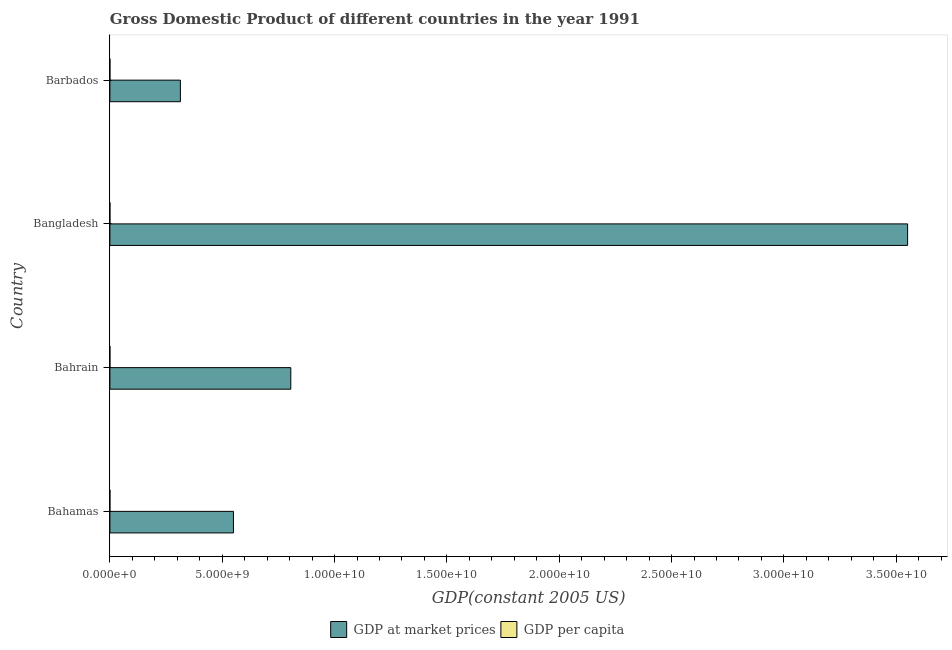Are the number of bars on each tick of the Y-axis equal?
Ensure brevity in your answer.  Yes. How many bars are there on the 4th tick from the bottom?
Provide a short and direct response. 2. What is the label of the 3rd group of bars from the top?
Give a very brief answer. Bahrain. In how many cases, is the number of bars for a given country not equal to the number of legend labels?
Keep it short and to the point. 0. What is the gdp at market prices in Bahamas?
Provide a succinct answer. 5.50e+09. Across all countries, what is the maximum gdp per capita?
Your answer should be very brief. 2.11e+04. Across all countries, what is the minimum gdp at market prices?
Offer a terse response. 3.14e+09. In which country was the gdp at market prices minimum?
Ensure brevity in your answer.  Barbados. What is the total gdp per capita in the graph?
Offer a very short reply. 4.92e+04. What is the difference between the gdp per capita in Bahrain and that in Barbados?
Your answer should be very brief. 3789.09. What is the difference between the gdp at market prices in Bahamas and the gdp per capita in Barbados?
Your answer should be very brief. 5.50e+09. What is the average gdp at market prices per country?
Make the answer very short. 1.30e+1. What is the difference between the gdp at market prices and gdp per capita in Bahrain?
Offer a very short reply. 8.05e+09. In how many countries, is the gdp per capita greater than 19000000000 US$?
Provide a succinct answer. 0. What is the ratio of the gdp per capita in Bahamas to that in Bangladesh?
Your answer should be compact. 64.36. What is the difference between the highest and the second highest gdp at market prices?
Provide a short and direct response. 2.75e+1. What is the difference between the highest and the lowest gdp per capita?
Offer a terse response. 2.07e+04. In how many countries, is the gdp at market prices greater than the average gdp at market prices taken over all countries?
Your answer should be compact. 1. Is the sum of the gdp per capita in Bahamas and Bahrain greater than the maximum gdp at market prices across all countries?
Offer a terse response. No. What does the 1st bar from the top in Bangladesh represents?
Ensure brevity in your answer.  GDP per capita. What does the 2nd bar from the bottom in Bangladesh represents?
Your answer should be very brief. GDP per capita. How many bars are there?
Provide a succinct answer. 8. How many countries are there in the graph?
Make the answer very short. 4. What is the difference between two consecutive major ticks on the X-axis?
Keep it short and to the point. 5.00e+09. Where does the legend appear in the graph?
Offer a very short reply. Bottom center. What is the title of the graph?
Offer a very short reply. Gross Domestic Product of different countries in the year 1991. What is the label or title of the X-axis?
Keep it short and to the point. GDP(constant 2005 US). What is the label or title of the Y-axis?
Your response must be concise. Country. What is the GDP(constant 2005 US) of GDP at market prices in Bahamas?
Make the answer very short. 5.50e+09. What is the GDP(constant 2005 US) of GDP per capita in Bahamas?
Your response must be concise. 2.11e+04. What is the GDP(constant 2005 US) in GDP at market prices in Bahrain?
Your answer should be compact. 8.05e+09. What is the GDP(constant 2005 US) of GDP per capita in Bahrain?
Your answer should be compact. 1.58e+04. What is the GDP(constant 2005 US) in GDP at market prices in Bangladesh?
Your answer should be very brief. 3.55e+1. What is the GDP(constant 2005 US) in GDP per capita in Bangladesh?
Provide a succinct answer. 327.21. What is the GDP(constant 2005 US) of GDP at market prices in Barbados?
Offer a terse response. 3.14e+09. What is the GDP(constant 2005 US) of GDP per capita in Barbados?
Your response must be concise. 1.20e+04. Across all countries, what is the maximum GDP(constant 2005 US) of GDP at market prices?
Your answer should be compact. 3.55e+1. Across all countries, what is the maximum GDP(constant 2005 US) of GDP per capita?
Make the answer very short. 2.11e+04. Across all countries, what is the minimum GDP(constant 2005 US) of GDP at market prices?
Give a very brief answer. 3.14e+09. Across all countries, what is the minimum GDP(constant 2005 US) in GDP per capita?
Your answer should be compact. 327.21. What is the total GDP(constant 2005 US) of GDP at market prices in the graph?
Keep it short and to the point. 5.22e+1. What is the total GDP(constant 2005 US) in GDP per capita in the graph?
Make the answer very short. 4.92e+04. What is the difference between the GDP(constant 2005 US) of GDP at market prices in Bahamas and that in Bahrain?
Provide a succinct answer. -2.55e+09. What is the difference between the GDP(constant 2005 US) in GDP per capita in Bahamas and that in Bahrain?
Your answer should be very brief. 5259.74. What is the difference between the GDP(constant 2005 US) in GDP at market prices in Bahamas and that in Bangladesh?
Your answer should be compact. -3.00e+1. What is the difference between the GDP(constant 2005 US) in GDP per capita in Bahamas and that in Bangladesh?
Give a very brief answer. 2.07e+04. What is the difference between the GDP(constant 2005 US) of GDP at market prices in Bahamas and that in Barbados?
Offer a very short reply. 2.36e+09. What is the difference between the GDP(constant 2005 US) in GDP per capita in Bahamas and that in Barbados?
Provide a succinct answer. 9048.83. What is the difference between the GDP(constant 2005 US) of GDP at market prices in Bahrain and that in Bangladesh?
Offer a terse response. -2.75e+1. What is the difference between the GDP(constant 2005 US) of GDP per capita in Bahrain and that in Bangladesh?
Give a very brief answer. 1.55e+04. What is the difference between the GDP(constant 2005 US) in GDP at market prices in Bahrain and that in Barbados?
Keep it short and to the point. 4.91e+09. What is the difference between the GDP(constant 2005 US) in GDP per capita in Bahrain and that in Barbados?
Give a very brief answer. 3789.09. What is the difference between the GDP(constant 2005 US) in GDP at market prices in Bangladesh and that in Barbados?
Give a very brief answer. 3.24e+1. What is the difference between the GDP(constant 2005 US) in GDP per capita in Bangladesh and that in Barbados?
Make the answer very short. -1.17e+04. What is the difference between the GDP(constant 2005 US) in GDP at market prices in Bahamas and the GDP(constant 2005 US) in GDP per capita in Bahrain?
Provide a succinct answer. 5.50e+09. What is the difference between the GDP(constant 2005 US) of GDP at market prices in Bahamas and the GDP(constant 2005 US) of GDP per capita in Bangladesh?
Your response must be concise. 5.50e+09. What is the difference between the GDP(constant 2005 US) of GDP at market prices in Bahamas and the GDP(constant 2005 US) of GDP per capita in Barbados?
Your answer should be very brief. 5.50e+09. What is the difference between the GDP(constant 2005 US) of GDP at market prices in Bahrain and the GDP(constant 2005 US) of GDP per capita in Bangladesh?
Provide a short and direct response. 8.05e+09. What is the difference between the GDP(constant 2005 US) in GDP at market prices in Bahrain and the GDP(constant 2005 US) in GDP per capita in Barbados?
Provide a short and direct response. 8.05e+09. What is the difference between the GDP(constant 2005 US) of GDP at market prices in Bangladesh and the GDP(constant 2005 US) of GDP per capita in Barbados?
Provide a short and direct response. 3.55e+1. What is the average GDP(constant 2005 US) of GDP at market prices per country?
Offer a very short reply. 1.30e+1. What is the average GDP(constant 2005 US) in GDP per capita per country?
Give a very brief answer. 1.23e+04. What is the difference between the GDP(constant 2005 US) of GDP at market prices and GDP(constant 2005 US) of GDP per capita in Bahamas?
Your response must be concise. 5.50e+09. What is the difference between the GDP(constant 2005 US) in GDP at market prices and GDP(constant 2005 US) in GDP per capita in Bahrain?
Ensure brevity in your answer.  8.05e+09. What is the difference between the GDP(constant 2005 US) in GDP at market prices and GDP(constant 2005 US) in GDP per capita in Bangladesh?
Keep it short and to the point. 3.55e+1. What is the difference between the GDP(constant 2005 US) in GDP at market prices and GDP(constant 2005 US) in GDP per capita in Barbados?
Your answer should be compact. 3.14e+09. What is the ratio of the GDP(constant 2005 US) of GDP at market prices in Bahamas to that in Bahrain?
Provide a short and direct response. 0.68. What is the ratio of the GDP(constant 2005 US) of GDP per capita in Bahamas to that in Bahrain?
Provide a succinct answer. 1.33. What is the ratio of the GDP(constant 2005 US) in GDP at market prices in Bahamas to that in Bangladesh?
Offer a terse response. 0.15. What is the ratio of the GDP(constant 2005 US) of GDP per capita in Bahamas to that in Bangladesh?
Make the answer very short. 64.36. What is the ratio of the GDP(constant 2005 US) of GDP at market prices in Bahamas to that in Barbados?
Provide a short and direct response. 1.75. What is the ratio of the GDP(constant 2005 US) in GDP per capita in Bahamas to that in Barbados?
Offer a very short reply. 1.75. What is the ratio of the GDP(constant 2005 US) in GDP at market prices in Bahrain to that in Bangladesh?
Your response must be concise. 0.23. What is the ratio of the GDP(constant 2005 US) of GDP per capita in Bahrain to that in Bangladesh?
Offer a terse response. 48.28. What is the ratio of the GDP(constant 2005 US) of GDP at market prices in Bahrain to that in Barbados?
Make the answer very short. 2.57. What is the ratio of the GDP(constant 2005 US) in GDP per capita in Bahrain to that in Barbados?
Provide a succinct answer. 1.32. What is the ratio of the GDP(constant 2005 US) in GDP at market prices in Bangladesh to that in Barbados?
Your response must be concise. 11.31. What is the ratio of the GDP(constant 2005 US) of GDP per capita in Bangladesh to that in Barbados?
Keep it short and to the point. 0.03. What is the difference between the highest and the second highest GDP(constant 2005 US) in GDP at market prices?
Provide a succinct answer. 2.75e+1. What is the difference between the highest and the second highest GDP(constant 2005 US) in GDP per capita?
Your answer should be compact. 5259.74. What is the difference between the highest and the lowest GDP(constant 2005 US) of GDP at market prices?
Make the answer very short. 3.24e+1. What is the difference between the highest and the lowest GDP(constant 2005 US) in GDP per capita?
Provide a succinct answer. 2.07e+04. 